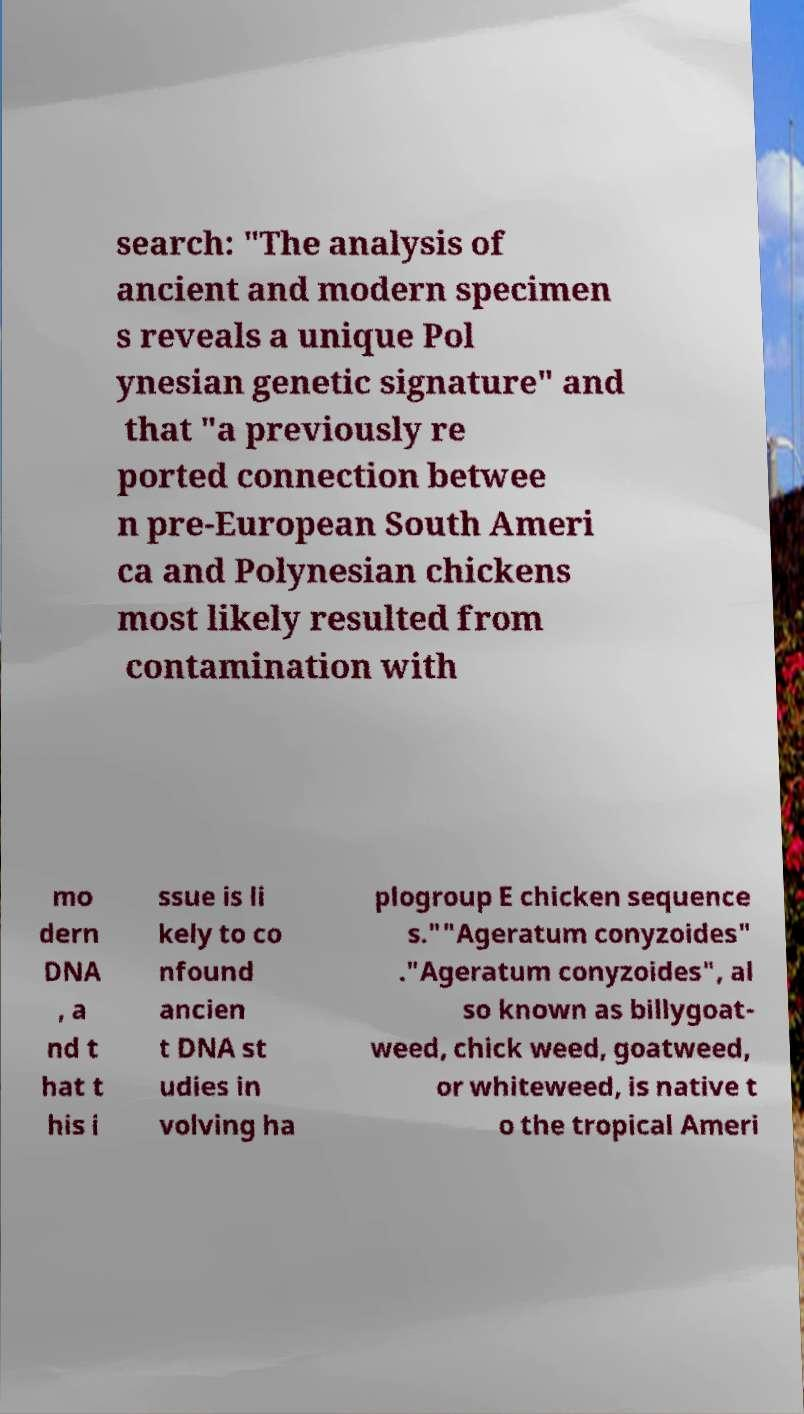Please identify and transcribe the text found in this image. search: "The analysis of ancient and modern specimen s reveals a unique Pol ynesian genetic signature" and that "a previously re ported connection betwee n pre-European South Ameri ca and Polynesian chickens most likely resulted from contamination with mo dern DNA , a nd t hat t his i ssue is li kely to co nfound ancien t DNA st udies in volving ha plogroup E chicken sequence s.""Ageratum conyzoides" ."Ageratum conyzoides", al so known as billygoat- weed, chick weed, goatweed, or whiteweed, is native t o the tropical Ameri 